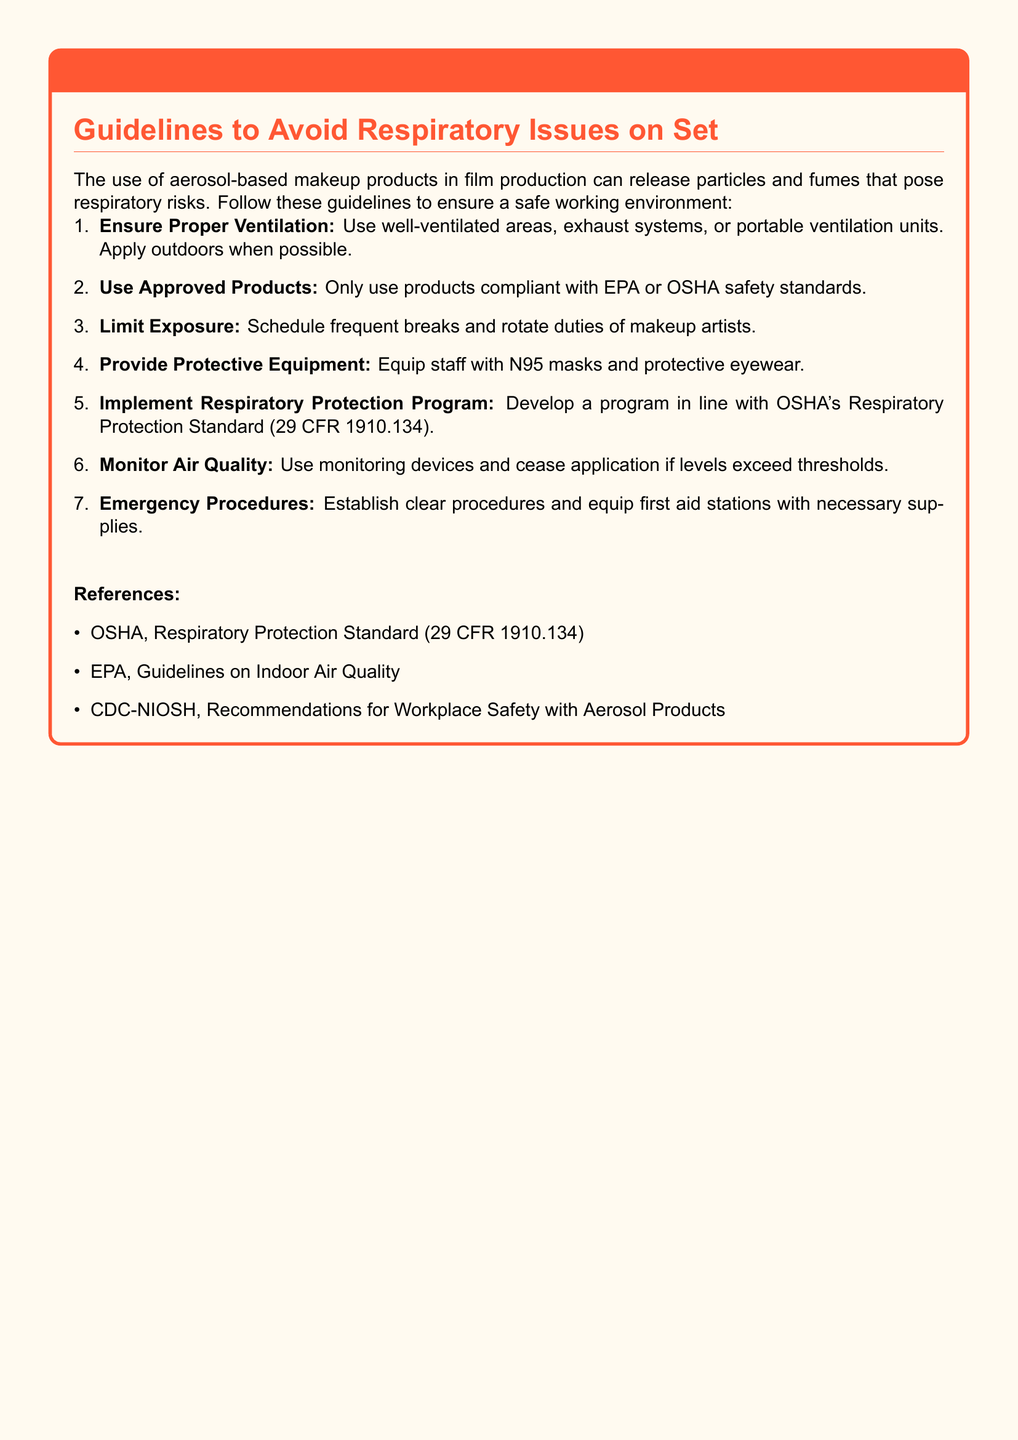what is the title of the warning label? The title of the warning label is explicitly stated at the top of the document in a warning color.
Answer: WARNING: Proper Ventilation for Aerosol-Based Makeup how many guidelines are provided? The number of guidelines is indicated by the total items listed in the enumerated list within the document.
Answer: Seven which type of protective equipment is recommended? The document specifies the type of protective equipment that should be provided to the staff, as listed in one of the guidelines.
Answer: N95 masks what standard should the respiratory protection program align with? The document refers to a specific standard that the respiratory protection program must be in line with, providing a clear reference.
Answer: OSHA's Respiratory Protection Standard (29 CFR 1910.134) what should be monitored to ensure safety? The document specifies what should be monitored in the workplace to maintain a safe environment for the use of aerosol-based products.
Answer: Air Quality what action should be taken if air quality levels exceed thresholds? The document outlines a specific action to be taken if the monitored levels exceed the safety thresholds during makeup application.
Answer: Cease application who provides the guidelines for workplace safety? The document lists the organizations that provide essential guidelines and standards for safety with aerosol products.
Answer: OSHA, EPA, CDC-NIOSH 